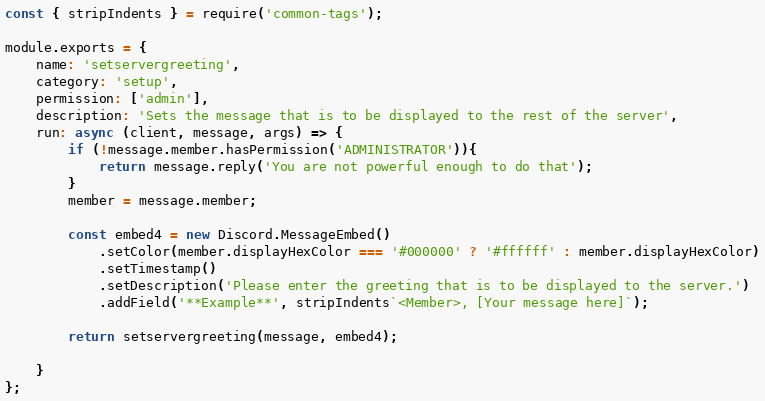<code> <loc_0><loc_0><loc_500><loc_500><_JavaScript_>const { stripIndents } = require('common-tags');

module.exports = {
	name: 'setservergreeting',    
	category: 'setup',
	permission: ['admin'],
	description: 'Sets the message that is to be displayed to the rest of the server',    
	run: async (client, message, args) => {
		if (!message.member.hasPermission('ADMINISTRATOR')){
			return message.reply('You are not powerful enough to do that');
		}
		member = message.member;

		const embed4 = new Discord.MessageEmbed()
			.setColor(member.displayHexColor === '#000000' ? '#ffffff' : member.displayHexColor)
			.setTimestamp()
			.setDescription('Please enter the greeting that is to be displayed to the server.')
			.addField('**Example**', stripIndents`<Member>, [Your message here]`);

		return setservergreeting(message, embed4);

	}
};</code> 